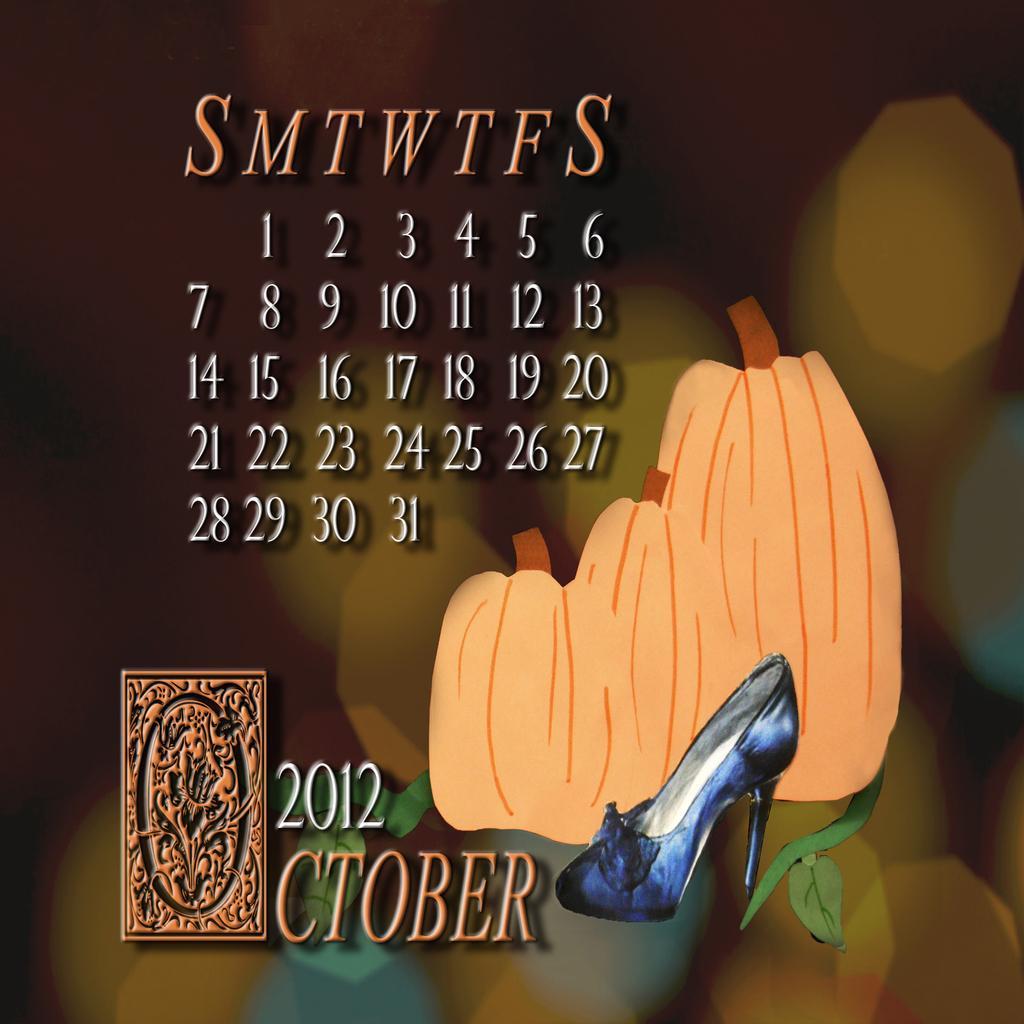Could you give a brief overview of what you see in this image? This is an advertisement. In this picture we can see the text and painting of fruits, shoe and a logo. In the background the image is blur. 